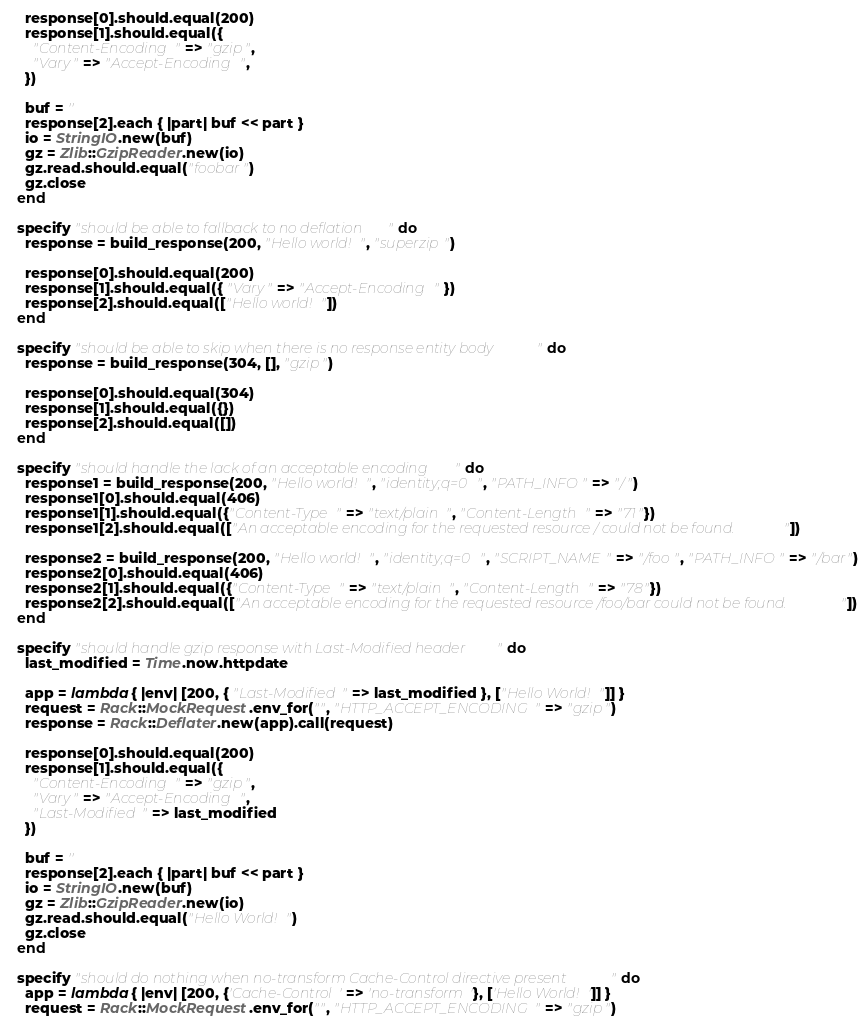Convert code to text. <code><loc_0><loc_0><loc_500><loc_500><_Ruby_>    response[0].should.equal(200)
    response[1].should.equal({
      "Content-Encoding" => "gzip",
      "Vary" => "Accept-Encoding",
    })

    buf = ''
    response[2].each { |part| buf << part }
    io = StringIO.new(buf)
    gz = Zlib::GzipReader.new(io)
    gz.read.should.equal("foobar")
    gz.close
  end

  specify "should be able to fallback to no deflation" do
    response = build_response(200, "Hello world!", "superzip")

    response[0].should.equal(200)
    response[1].should.equal({ "Vary" => "Accept-Encoding" })
    response[2].should.equal(["Hello world!"])
  end

  specify "should be able to skip when there is no response entity body" do
    response = build_response(304, [], "gzip")

    response[0].should.equal(304)
    response[1].should.equal({})
    response[2].should.equal([])
  end

  specify "should handle the lack of an acceptable encoding" do
    response1 = build_response(200, "Hello world!", "identity;q=0", "PATH_INFO" => "/")
    response1[0].should.equal(406)
    response1[1].should.equal({"Content-Type" => "text/plain", "Content-Length" => "71"})
    response1[2].should.equal(["An acceptable encoding for the requested resource / could not be found."])

    response2 = build_response(200, "Hello world!", "identity;q=0", "SCRIPT_NAME" => "/foo", "PATH_INFO" => "/bar")
    response2[0].should.equal(406)
    response2[1].should.equal({"Content-Type" => "text/plain", "Content-Length" => "78"})
    response2[2].should.equal(["An acceptable encoding for the requested resource /foo/bar could not be found."])
  end

  specify "should handle gzip response with Last-Modified header" do
    last_modified = Time.now.httpdate

    app = lambda { |env| [200, { "Last-Modified" => last_modified }, ["Hello World!"]] }
    request = Rack::MockRequest.env_for("", "HTTP_ACCEPT_ENCODING" => "gzip")
    response = Rack::Deflater.new(app).call(request)

    response[0].should.equal(200)
    response[1].should.equal({
      "Content-Encoding" => "gzip",
      "Vary" => "Accept-Encoding",
      "Last-Modified" => last_modified
    })

    buf = ''
    response[2].each { |part| buf << part }
    io = StringIO.new(buf)
    gz = Zlib::GzipReader.new(io)
    gz.read.should.equal("Hello World!")
    gz.close
  end

  specify "should do nothing when no-transform Cache-Control directive present" do
    app = lambda { |env| [200, {'Cache-Control' => 'no-transform'}, ['Hello World!']] }
    request = Rack::MockRequest.env_for("", "HTTP_ACCEPT_ENCODING" => "gzip")</code> 